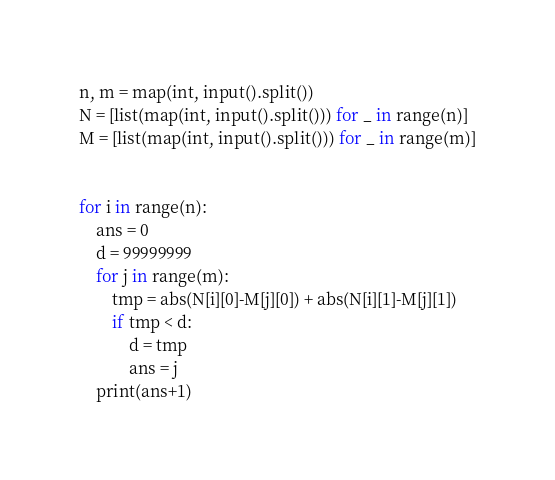<code> <loc_0><loc_0><loc_500><loc_500><_Python_>n, m = map(int, input().split())
N = [list(map(int, input().split())) for _ in range(n)]
M = [list(map(int, input().split())) for _ in range(m)]


for i in range(n):
    ans = 0
    d = 99999999
    for j in range(m):
        tmp = abs(N[i][0]-M[j][0]) + abs(N[i][1]-M[j][1])
        if tmp < d:
            d = tmp
            ans = j
    print(ans+1)</code> 